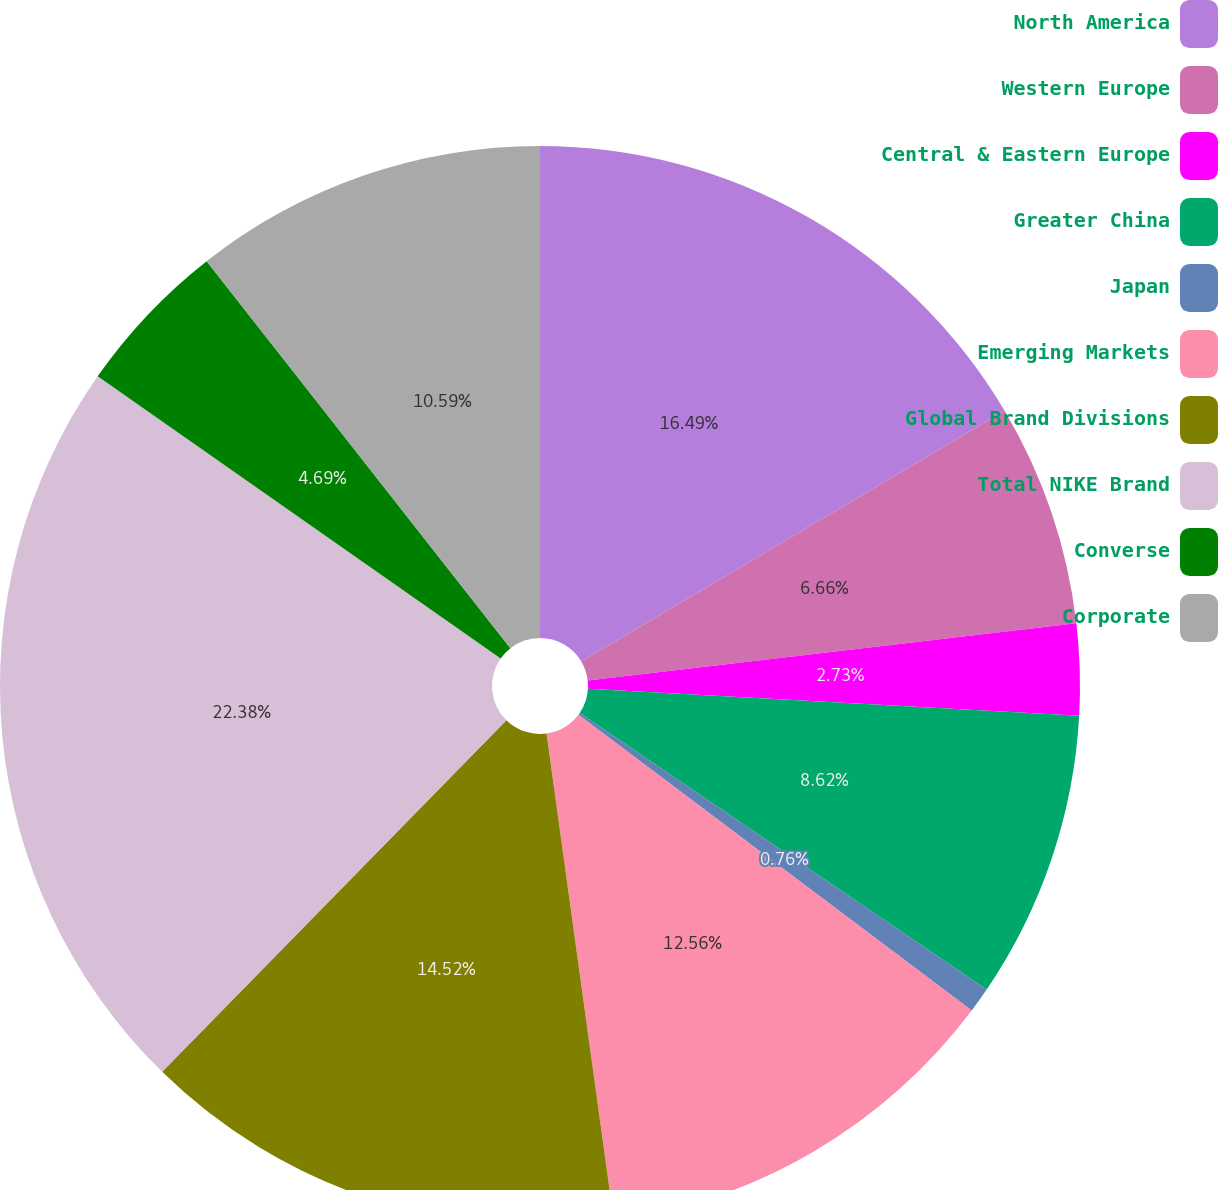<chart> <loc_0><loc_0><loc_500><loc_500><pie_chart><fcel>North America<fcel>Western Europe<fcel>Central & Eastern Europe<fcel>Greater China<fcel>Japan<fcel>Emerging Markets<fcel>Global Brand Divisions<fcel>Total NIKE Brand<fcel>Converse<fcel>Corporate<nl><fcel>16.49%<fcel>6.66%<fcel>2.73%<fcel>8.62%<fcel>0.76%<fcel>12.56%<fcel>14.52%<fcel>22.39%<fcel>4.69%<fcel>10.59%<nl></chart> 